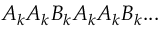<formula> <loc_0><loc_0><loc_500><loc_500>A _ { k } A _ { k } B _ { k } A _ { k } A _ { k } B _ { k } \dots</formula> 